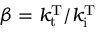Convert formula to latex. <formula><loc_0><loc_0><loc_500><loc_500>\beta = k _ { t } ^ { T } / k _ { i } ^ { T }</formula> 